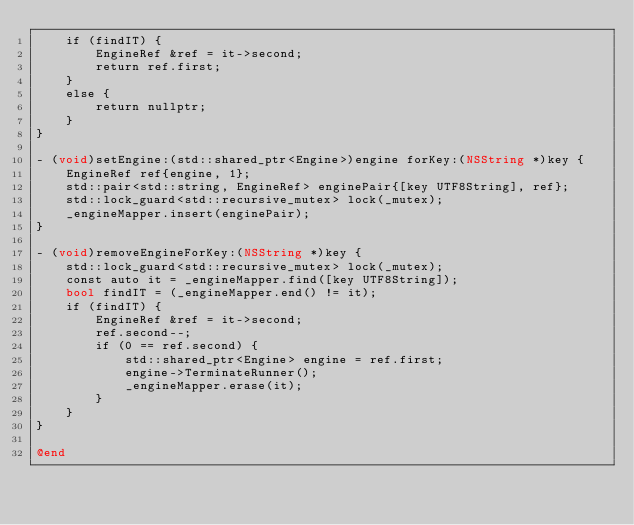Convert code to text. <code><loc_0><loc_0><loc_500><loc_500><_ObjectiveC_>    if (findIT) {
        EngineRef &ref = it->second;
        return ref.first;
    }
    else {
        return nullptr;
    }
}

- (void)setEngine:(std::shared_ptr<Engine>)engine forKey:(NSString *)key {
    EngineRef ref{engine, 1};
    std::pair<std::string, EngineRef> enginePair{[key UTF8String], ref};
    std::lock_guard<std::recursive_mutex> lock(_mutex);
    _engineMapper.insert(enginePair);
}

- (void)removeEngineForKey:(NSString *)key {
    std::lock_guard<std::recursive_mutex> lock(_mutex);
    const auto it = _engineMapper.find([key UTF8String]);
    bool findIT = (_engineMapper.end() != it);
    if (findIT) {
        EngineRef &ref = it->second;
        ref.second--;
        if (0 == ref.second) {
            std::shared_ptr<Engine> engine = ref.first;
            engine->TerminateRunner();
            _engineMapper.erase(it);
        }
    }
}

@end
</code> 